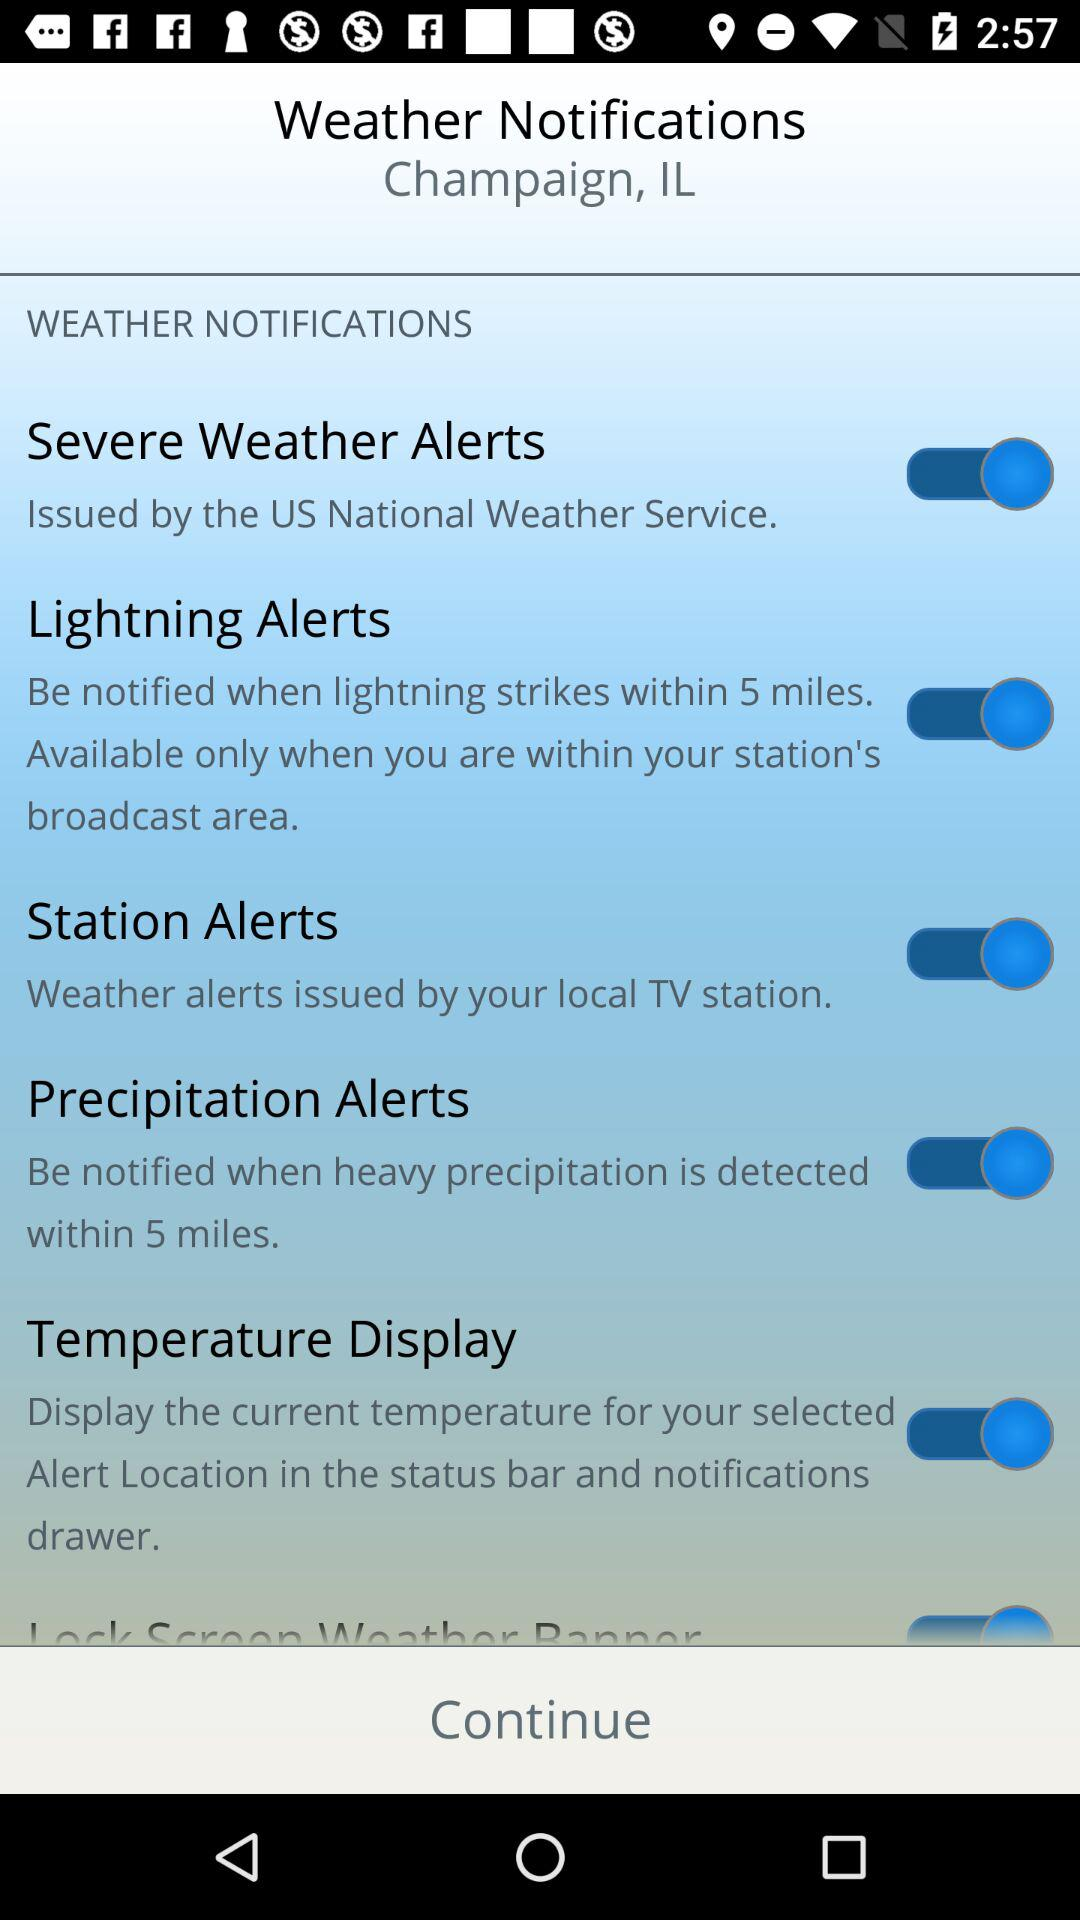What is the status of "Severe Weather Alerts"? The status is "on". 